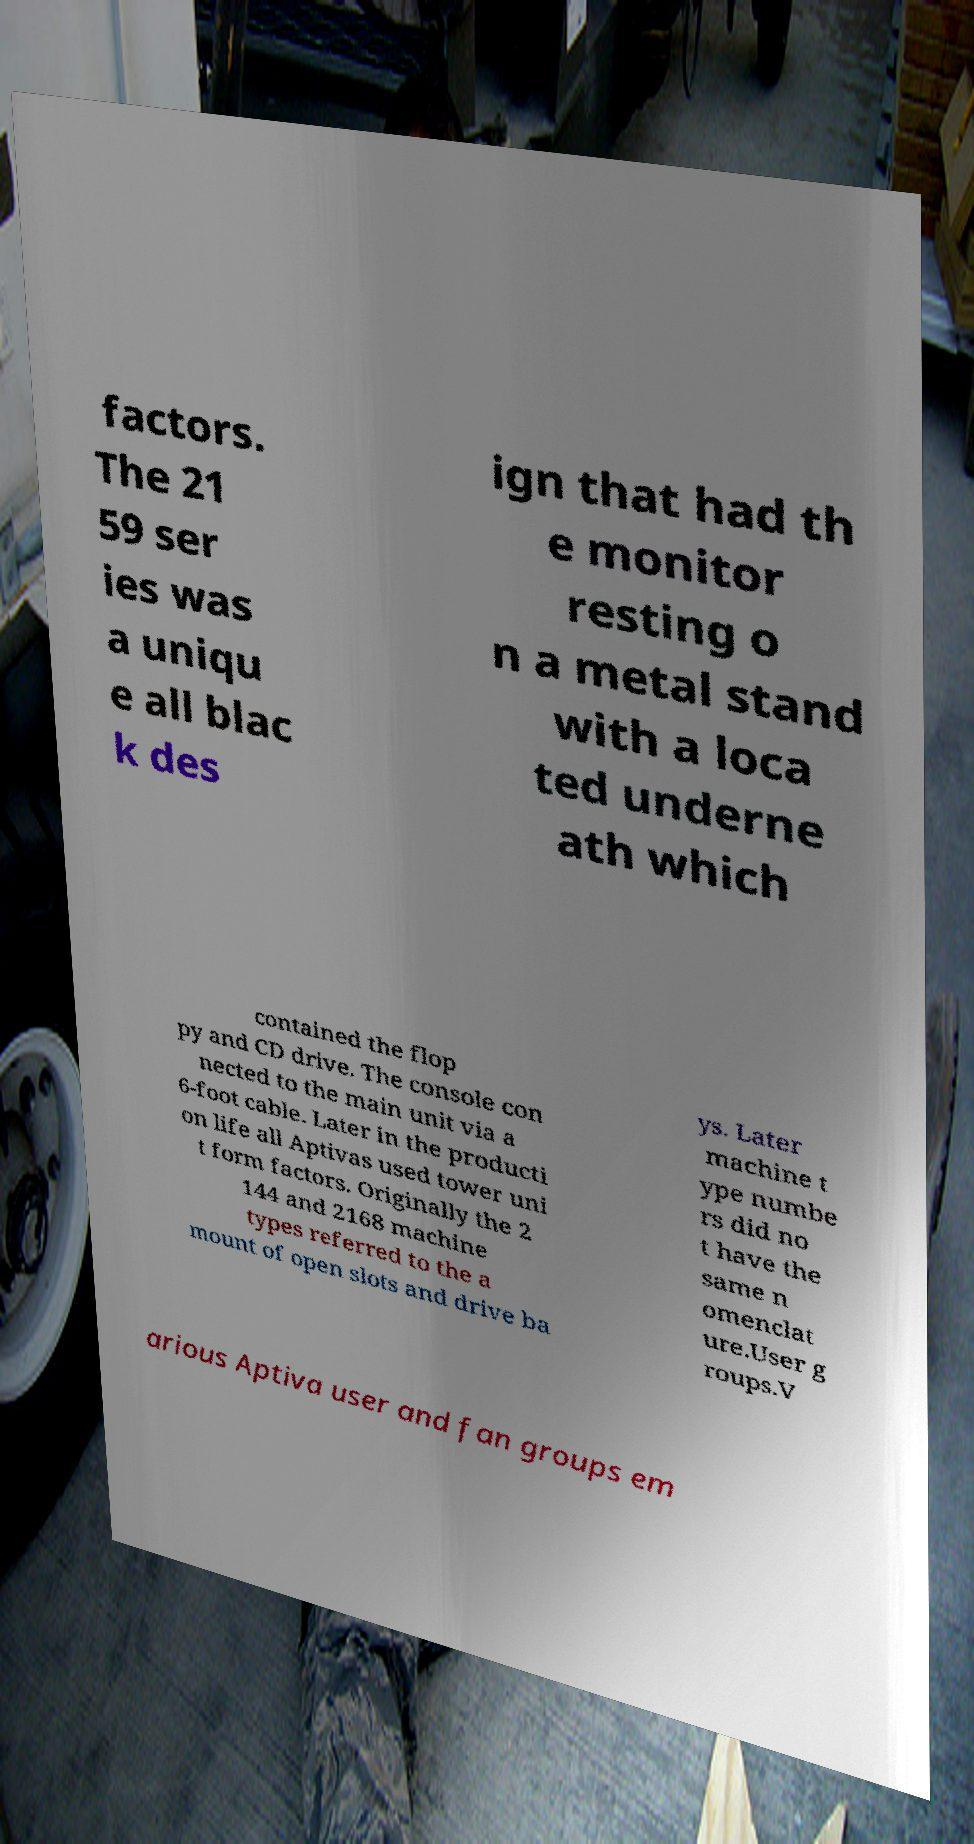What messages or text are displayed in this image? I need them in a readable, typed format. factors. The 21 59 ser ies was a uniqu e all blac k des ign that had th e monitor resting o n a metal stand with a loca ted underne ath which contained the flop py and CD drive. The console con nected to the main unit via a 6-foot cable. Later in the producti on life all Aptivas used tower uni t form factors. Originally the 2 144 and 2168 machine types referred to the a mount of open slots and drive ba ys. Later machine t ype numbe rs did no t have the same n omenclat ure.User g roups.V arious Aptiva user and fan groups em 